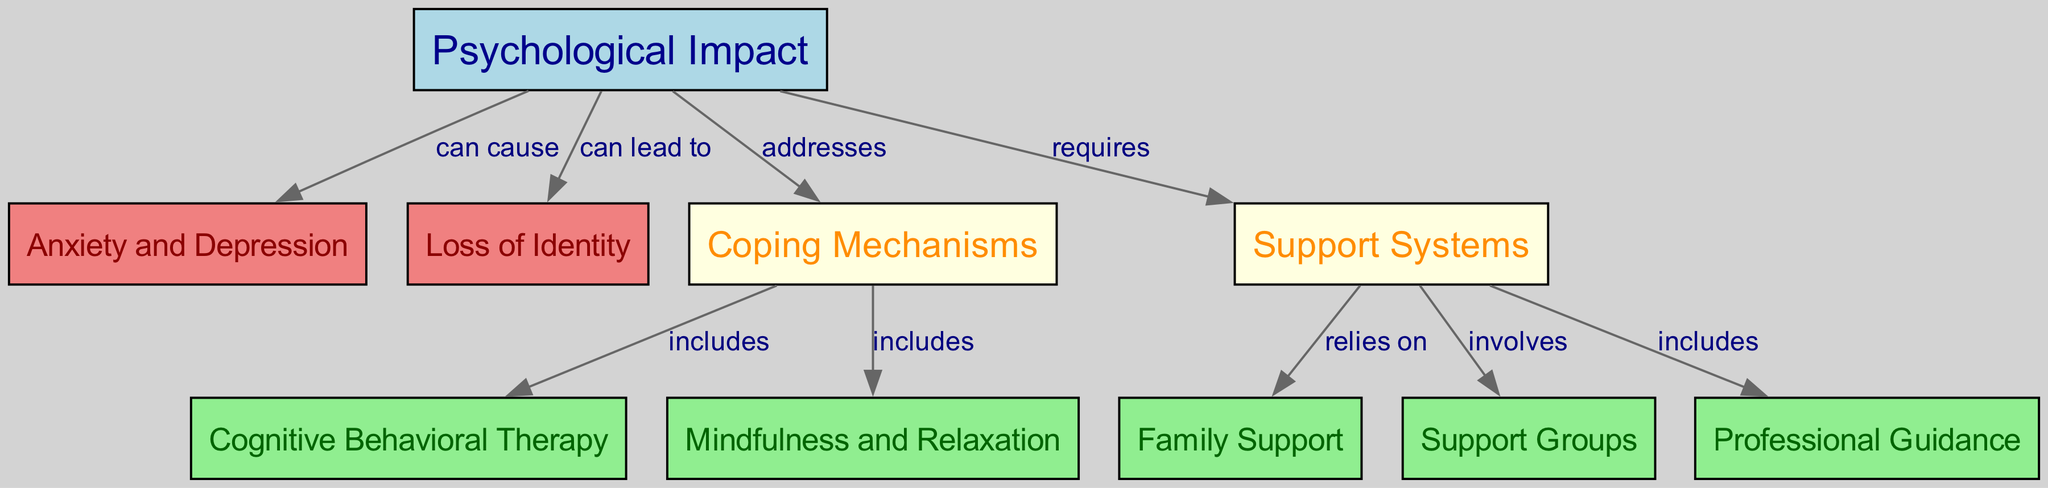What is the key psychological impact of running-related injuries? The diagram identifies "Psychological Impact" as the central theme, showing that running-related injuries can result in several psychological conditions.
Answer: Psychological Impact How many support systems are listed in the diagram? In the diagram, three support systems are mentioned: Family Support, Support Groups, and Professional Guidance. Counting these, we find there are three distinct support systems.
Answer: 3 Which two psychological conditions result from the psychological impact? The diagram shows two specific conditions stemming from the "Psychological Impact": Anxiety and Depression, and Loss of Identity. Thus, these are the two noted consequences.
Answer: Anxiety and Depression, Loss of Identity What coping mechanism is included in the diagram related to psychological impact? The diagram illustrates that "Coping Mechanisms" address the psychological impact. Under this category, it lists specific examples, one being Cognitive Behavioral Therapy and another being Mindfulness and Relaxation.
Answer: Coping Mechanisms Which support system involves sharing with others? The edge connecting "Support Systems" to "Support Groups" indicates that one of the support systems involves community sharing and interaction. Thus, "Support Groups" is the answer here.
Answer: Support Groups What is the relationship between Coping Mechanisms and Cognitive Behavioral Therapy? The diagram indicates that Coping Mechanisms include various strategies for addressing psychological impacts, of which Cognitive Behavioral Therapy is one option. Therefore, the relationship shows that one is a part of the other.
Answer: includes How do psychological impacts require support? The diagram connects the "Psychological Impact" node to the "Support Systems" node, suggesting a necessary relationship. This indicates that coping with the psychological effects of running-related injuries necessitates some form of support.
Answer: requires Which coping mechanism focuses on mental state improvement? The node "Mindfulness and Relaxation" listed under Coping Mechanisms indicates a focus on enhancing mental state and emotional well-being, giving those affected a way to cope effectively.
Answer: Mindfulness and Relaxation What role does family play in support systems? The edge indicating "Family Support" stemming from "Support Systems" demonstrates that family is a crucial part of providing emotional and practical support to someone dealing with the psychological impacts of running-related injuries.
Answer: relies on 